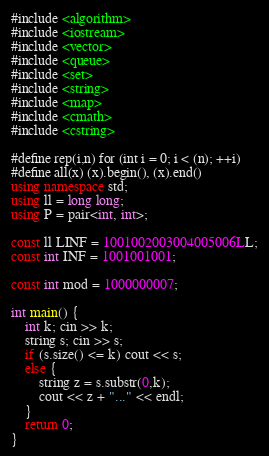<code> <loc_0><loc_0><loc_500><loc_500><_C++_>#include <algorithm>
#include <iostream>
#include <vector>
#include <queue>
#include <set>
#include <string>
#include <map>
#include <cmath>
#include <cstring>

#define rep(i,n) for (int i = 0; i < (n); ++i)
#define all(x) (x).begin(), (x).end()
using namespace std;
using ll = long long;
using P = pair<int, int>;

const ll LINF = 1001002003004005006LL;
const int INF = 1001001001;

const int mod = 1000000007;

int main() {
    int k; cin >> k;
    string s; cin >> s;
    if (s.size() <= k) cout << s;
    else {
        string z = s.substr(0,k);
        cout << z + "..." << endl;
    } 
    return 0;
}</code> 